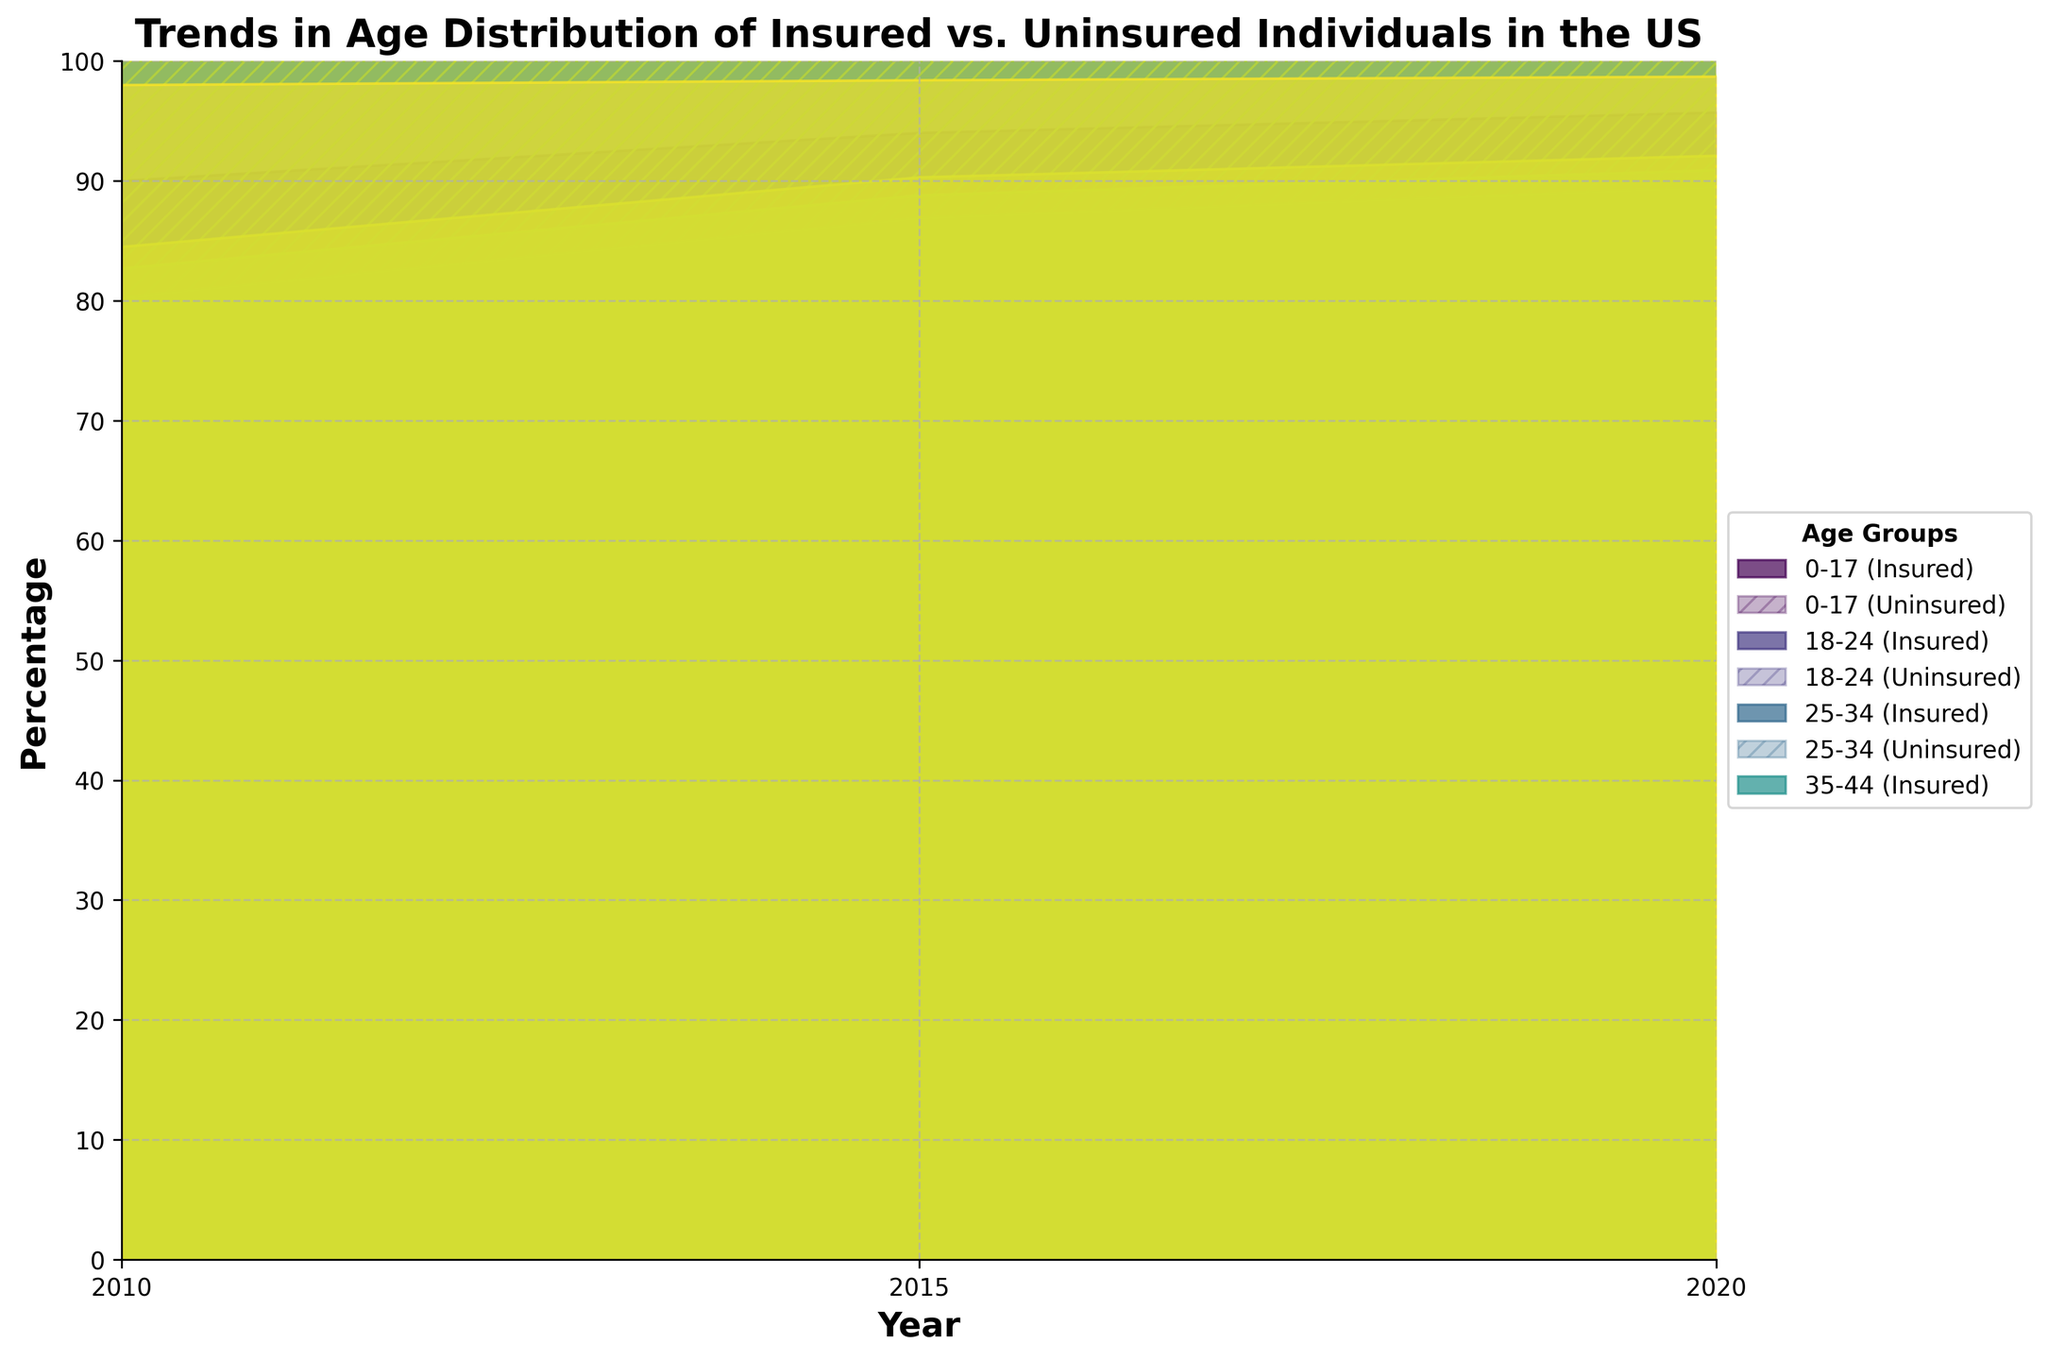What is the title of the figure? The title of the figure is displayed at the top and reads "Trends in Age Distribution of Insured vs. Uninsured Individuals in the US."
Answer: Trends in Age Distribution of Insured vs. Uninsured Individuals in the US Which age group has the highest insured percentage in 2020? By looking at the 'Insured Percent' values on the chart for the year 2020, the age group '65+' shows the highest insured percentage at 98.7%.
Answer: 65+ How has the uninsured percentage changed for the 18-24 age group from 2010 to 2020? Observing the 'Uninsured Percent' values for the 18-24 age group, it has decreased from 30.0% in 2010 to 17.7% in 2020.
Answer: It has decreased Which age group had the smallest change in the uninsured percentage from 2010 to 2020? By comparing the change in uninsured percentages for all age groups between 2010 and 2020, the 65+ group shows the smallest change, decreasing from 2.0% to 1.3%.
Answer: 65+ What is the difference in the insured percentage between the 25-34 and 35-44 age groups in 2015? For 2015, subtract 83.1% (insured percentage of 25-34) from 86.9% (insured percentage of 35-44): 86.9% - 83.1% = 3.8%.
Answer: 3.8% Which age group showed the greatest increase in insured percentage from 2010 to 2020? Calculating the increase for each group, 18-24 increased by 12.3% (from 70.0% to 82.3%), which is the largest increase among all age groups.
Answer: 18-24 How does the insured percentage trend for the 0-17 age group compare with the 45-54 age group from 2010 to 2020? Both the 0-17 and 45-54 age groups show an increasing trend in insured percentage; for 0-17, it rose from 90.0% to 95.7%, and for 45-54, from 82.7% to 90.9%. Therefore, both trends are similarly positive but with different starting points.
Answer: Both increased, but the 0-17 group started higher What is the range (maximum - minimum) of the insured percentage for the 35-44 age group across all years? The insured percentages for 35-44 are 80.3% (2010), 86.9% (2015), and 89.5% (2020). The range is calculated as 89.5% - 80.3% = 9.2%.
Answer: 9.2% What trend can be observed in the uninsured percentage for the 55-64 age group over the years? The uninsured percentage for the 55-64 age group shows a decreasing trend over the years: 15.5% (2010), 9.7% (2015), and 7.9% (2020).
Answer: Decreasing Which age groups had their insured percentage above 85% in 2020? From the chart, the 0-17, 25-34, 35-44, 45-54, 55-64, and 65+ age groups all had their insured percentages above 85% in 2020.
Answer: 0-17, 25-34, 35-44, 45-54, 55-64, 65+ 